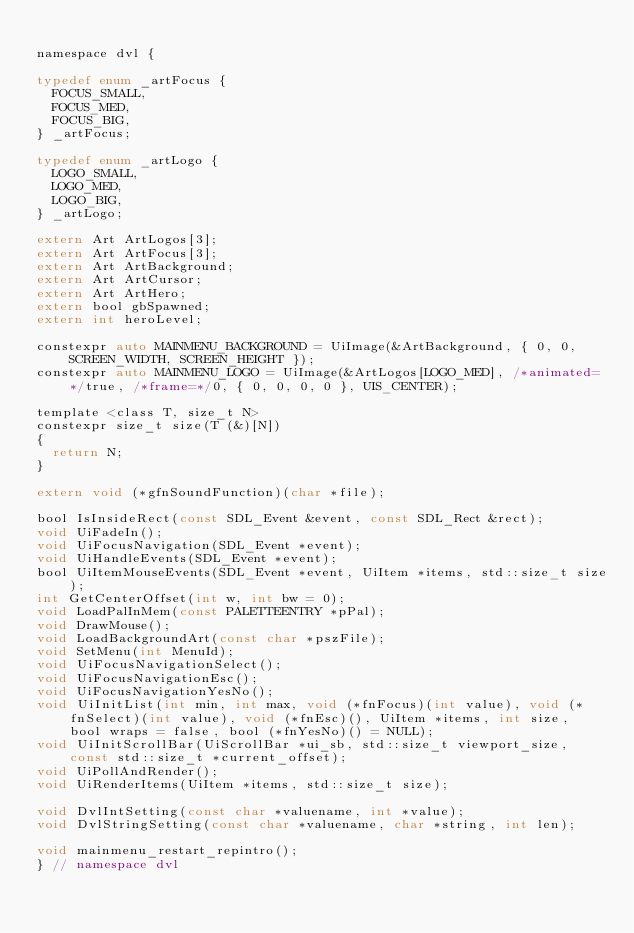Convert code to text. <code><loc_0><loc_0><loc_500><loc_500><_C_>
namespace dvl {

typedef enum _artFocus {
	FOCUS_SMALL,
	FOCUS_MED,
	FOCUS_BIG,
} _artFocus;

typedef enum _artLogo {
	LOGO_SMALL,
	LOGO_MED,
	LOGO_BIG,
} _artLogo;

extern Art ArtLogos[3];
extern Art ArtFocus[3];
extern Art ArtBackground;
extern Art ArtCursor;
extern Art ArtHero;
extern bool gbSpawned;
extern int heroLevel;

constexpr auto MAINMENU_BACKGROUND = UiImage(&ArtBackground, { 0, 0, SCREEN_WIDTH, SCREEN_HEIGHT });
constexpr auto MAINMENU_LOGO = UiImage(&ArtLogos[LOGO_MED], /*animated=*/true, /*frame=*/0, { 0, 0, 0, 0 }, UIS_CENTER);

template <class T, size_t N>
constexpr size_t size(T (&)[N])
{
	return N;
}

extern void (*gfnSoundFunction)(char *file);

bool IsInsideRect(const SDL_Event &event, const SDL_Rect &rect);
void UiFadeIn();
void UiFocusNavigation(SDL_Event *event);
void UiHandleEvents(SDL_Event *event);
bool UiItemMouseEvents(SDL_Event *event, UiItem *items, std::size_t size);
int GetCenterOffset(int w, int bw = 0);
void LoadPalInMem(const PALETTEENTRY *pPal);
void DrawMouse();
void LoadBackgroundArt(const char *pszFile);
void SetMenu(int MenuId);
void UiFocusNavigationSelect();
void UiFocusNavigationEsc();
void UiFocusNavigationYesNo();
void UiInitList(int min, int max, void (*fnFocus)(int value), void (*fnSelect)(int value), void (*fnEsc)(), UiItem *items, int size, bool wraps = false, bool (*fnYesNo)() = NULL);
void UiInitScrollBar(UiScrollBar *ui_sb, std::size_t viewport_size, const std::size_t *current_offset);
void UiPollAndRender();
void UiRenderItems(UiItem *items, std::size_t size);

void DvlIntSetting(const char *valuename, int *value);
void DvlStringSetting(const char *valuename, char *string, int len);

void mainmenu_restart_repintro();
} // namespace dvl
</code> 